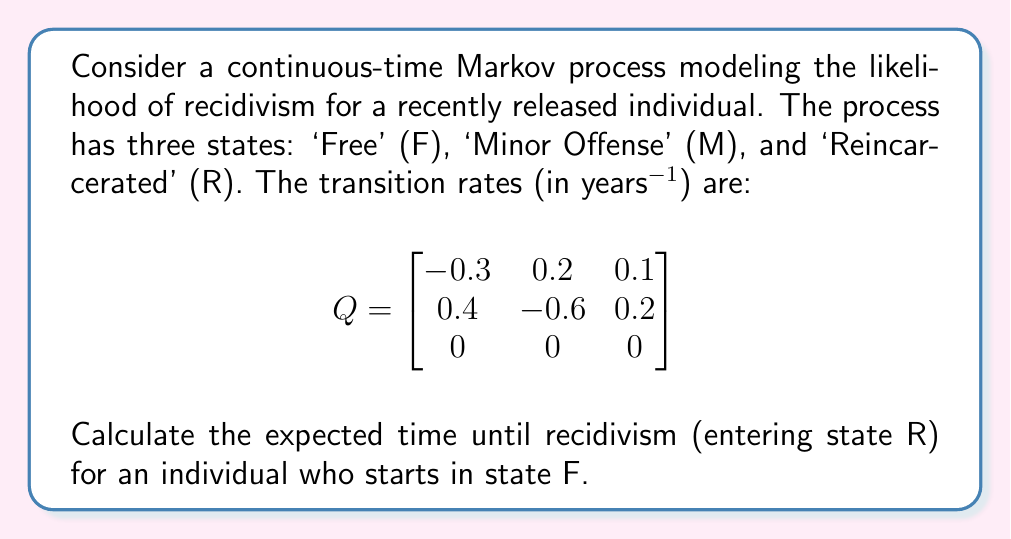Show me your answer to this math problem. To solve this problem, we'll use the theory of absorbing Markov chains:

1) First, we identify that state R is an absorbing state (once entered, it cannot be left).

2) We rearrange the Q matrix to put the absorbing state last:

   $$
   Q = \begin{bmatrix}
   -0.3 & 0.2 & 0.1 \\
   0.4 & -0.6 & 0.2 \\
   0 & 0 & 0
   \end{bmatrix}
   $$

3) We partition Q into submatrices:
   
   $$
   Q = \begin{bmatrix}
   T & R \\
   0 & 0
   \end{bmatrix}
   $$

   Where $T = \begin{bmatrix} -0.3 & 0.2 \\ 0.4 & -0.6 \end{bmatrix}$ and $R = \begin{bmatrix} 0.1 \\ 0.2 \end{bmatrix}$

4) The fundamental matrix N is given by $N = -T^{-1}$. Let's calculate this:

   $$T^{-1} = \frac{1}{(-0.3)(-0.6) - (0.2)(0.4)} \begin{bmatrix} -0.6 & -0.2 \\ -0.4 & -0.3 \end{bmatrix} = \begin{bmatrix} 2.5 & 0.833 \\ 1.667 & 1.25 \end{bmatrix}$$

   $$N = -T^{-1} = \begin{bmatrix} -2.5 & -0.833 \\ -1.667 & -1.25 \end{bmatrix}$$

5) The expected time to absorption (recidivism) is given by the sum of the entries in the first row of N (as we start in state F):

   Expected time = 2.5 + 0.833 = 3.333 years
Answer: 3.333 years 